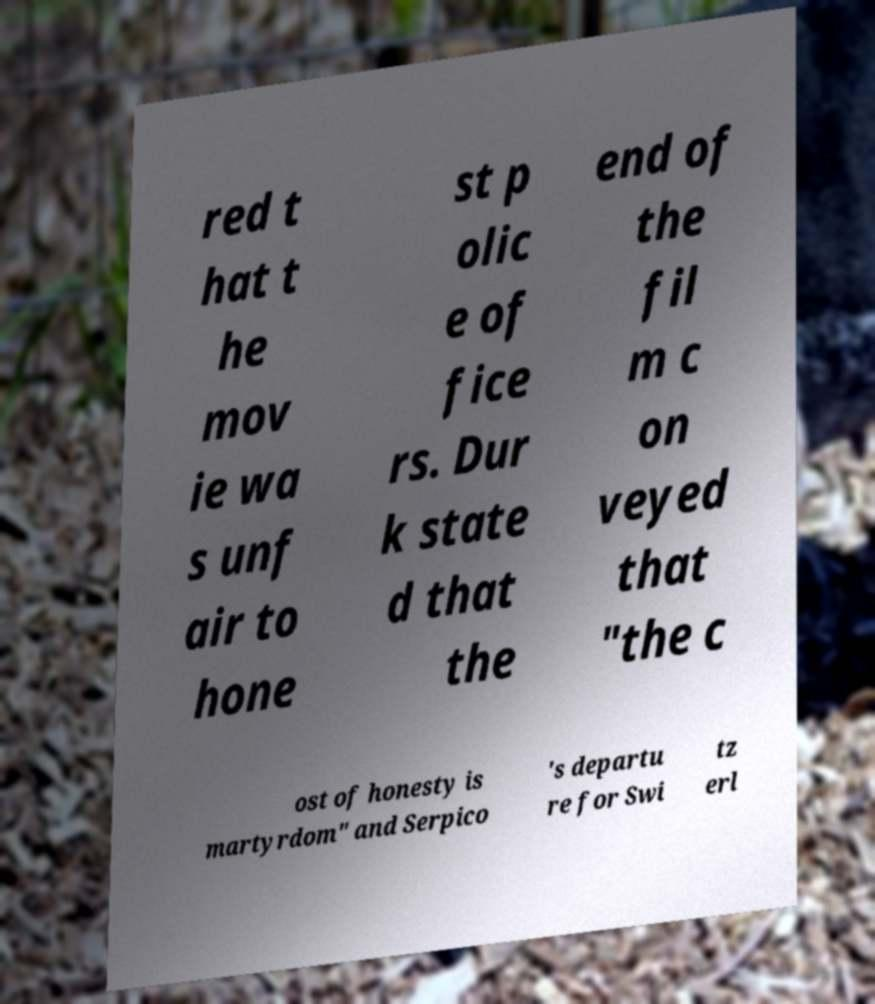Can you accurately transcribe the text from the provided image for me? red t hat t he mov ie wa s unf air to hone st p olic e of fice rs. Dur k state d that the end of the fil m c on veyed that "the c ost of honesty is martyrdom" and Serpico 's departu re for Swi tz erl 